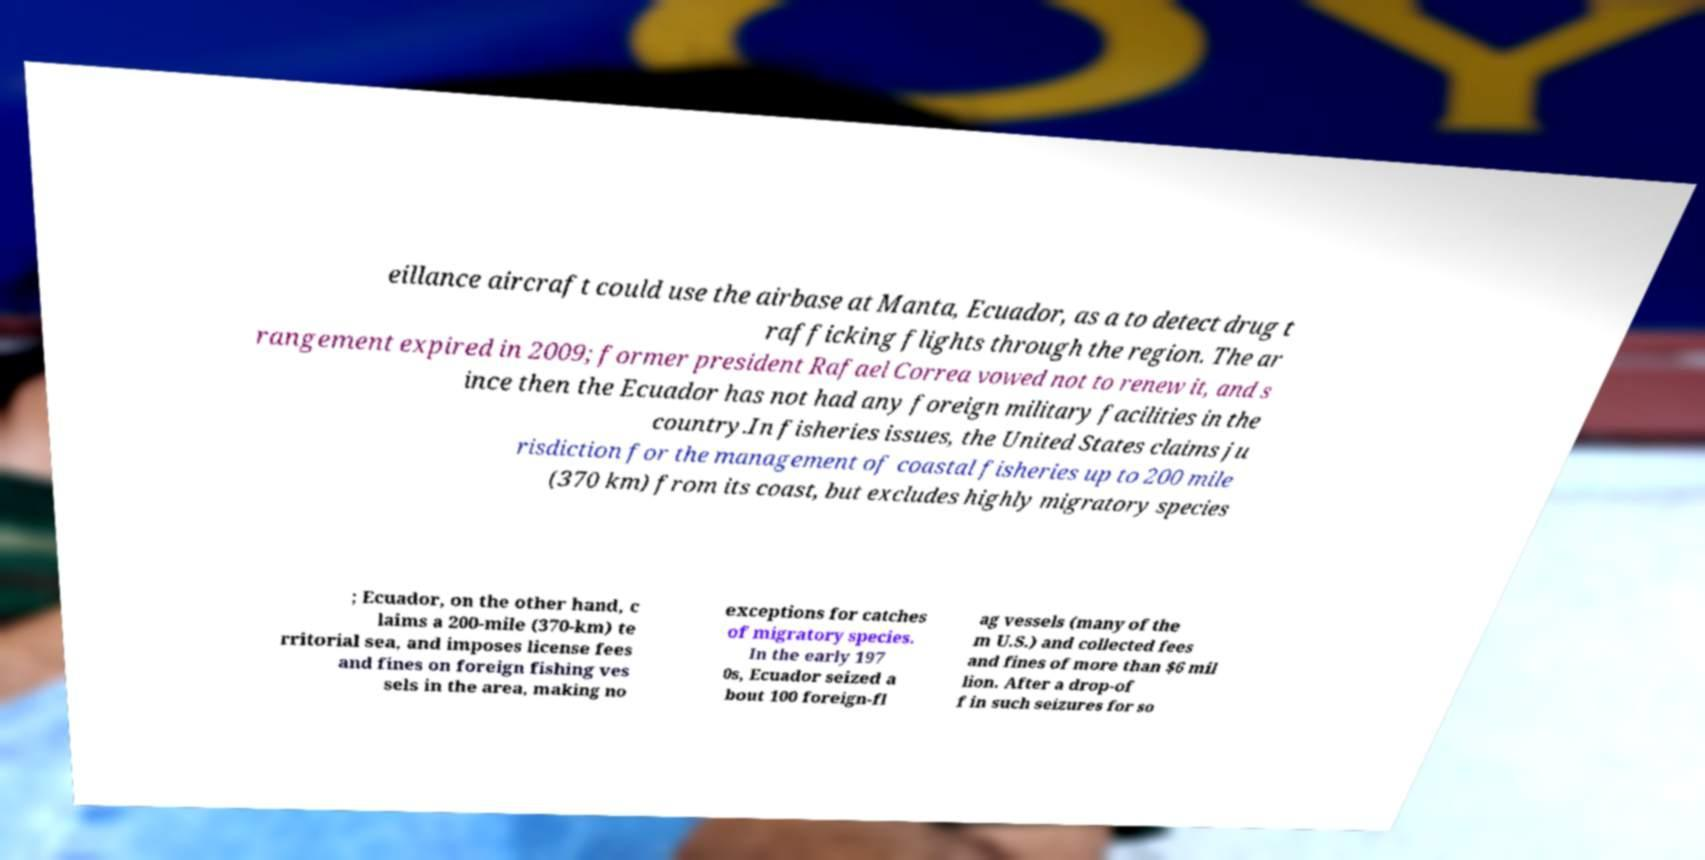Could you assist in decoding the text presented in this image and type it out clearly? eillance aircraft could use the airbase at Manta, Ecuador, as a to detect drug t rafficking flights through the region. The ar rangement expired in 2009; former president Rafael Correa vowed not to renew it, and s ince then the Ecuador has not had any foreign military facilities in the country.In fisheries issues, the United States claims ju risdiction for the management of coastal fisheries up to 200 mile (370 km) from its coast, but excludes highly migratory species ; Ecuador, on the other hand, c laims a 200-mile (370-km) te rritorial sea, and imposes license fees and fines on foreign fishing ves sels in the area, making no exceptions for catches of migratory species. In the early 197 0s, Ecuador seized a bout 100 foreign-fl ag vessels (many of the m U.S.) and collected fees and fines of more than $6 mil lion. After a drop-of f in such seizures for so 